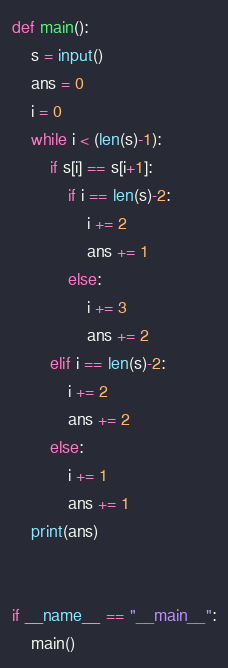Convert code to text. <code><loc_0><loc_0><loc_500><loc_500><_Python_>

def main():
    s = input()
    ans = 0
    i = 0
    while i < (len(s)-1):
        if s[i] == s[i+1]:
            if i == len(s)-2:
                i += 2
                ans += 1
            else:
                i += 3
                ans += 2
        elif i == len(s)-2:
            i += 2
            ans += 2
        else:
            i += 1
            ans += 1
    print(ans)


if __name__ == "__main__":
    main()</code> 